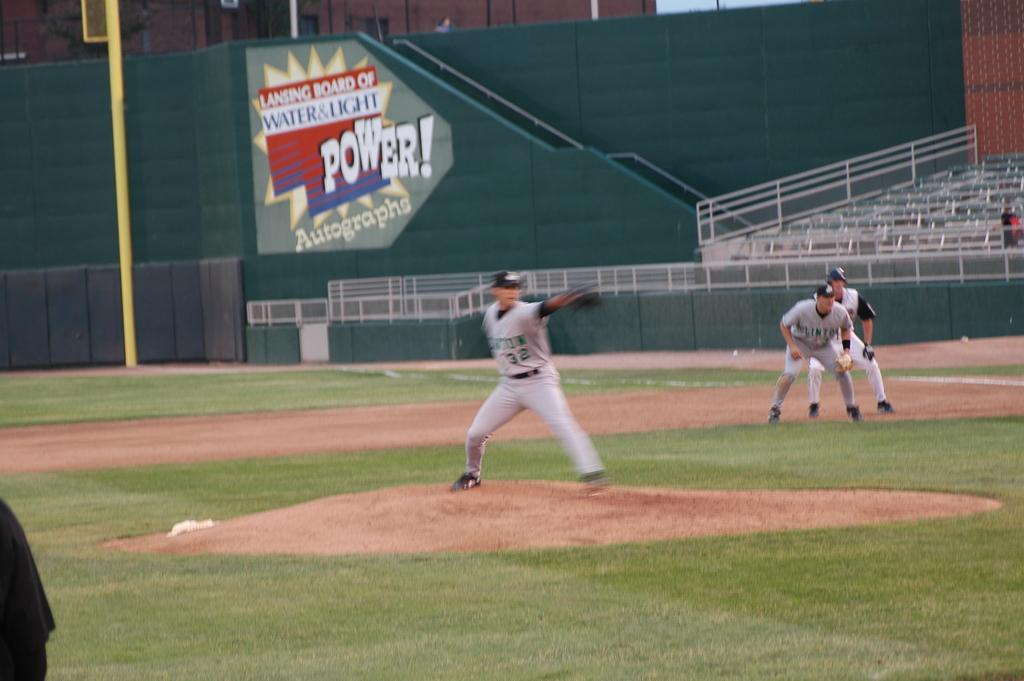<image>
Share a concise interpretation of the image provided. the word power is on an ad next to the field 